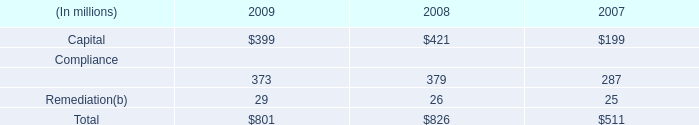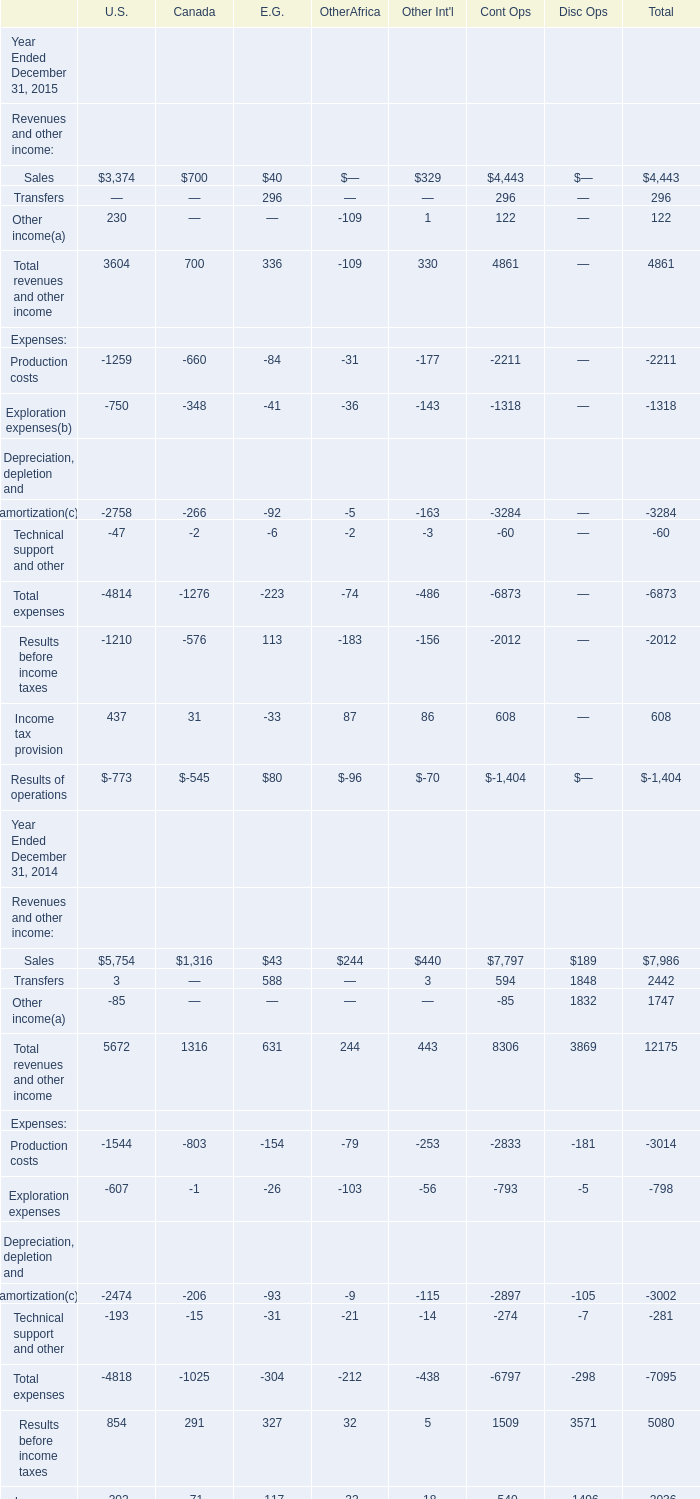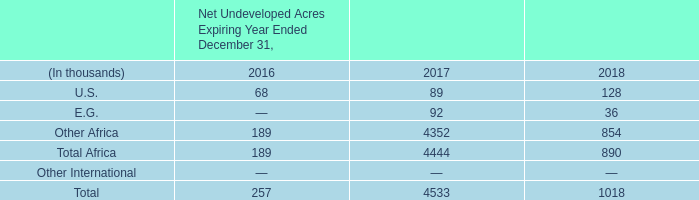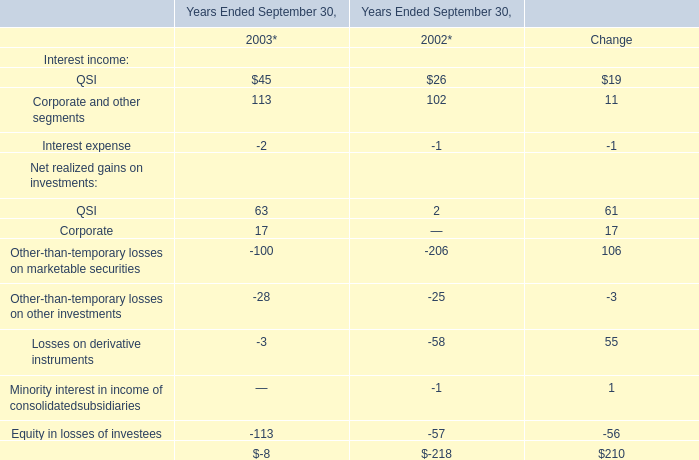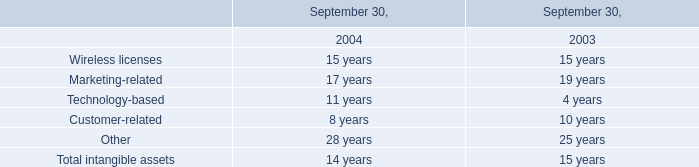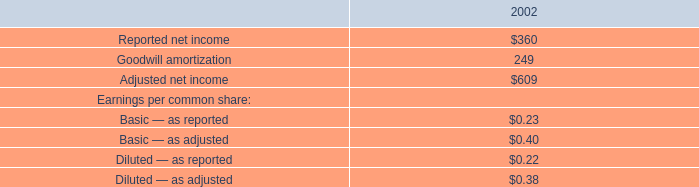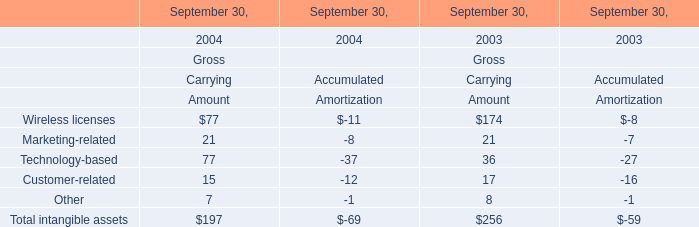What was the total amount of Revenues and other income excluding those Revenues and other income greater than 400 in 2015 for Cont Ops? 
Computations: (296 + 122)
Answer: 418.0. 